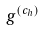<formula> <loc_0><loc_0><loc_500><loc_500>g ^ { ( c _ { h } ) }</formula> 